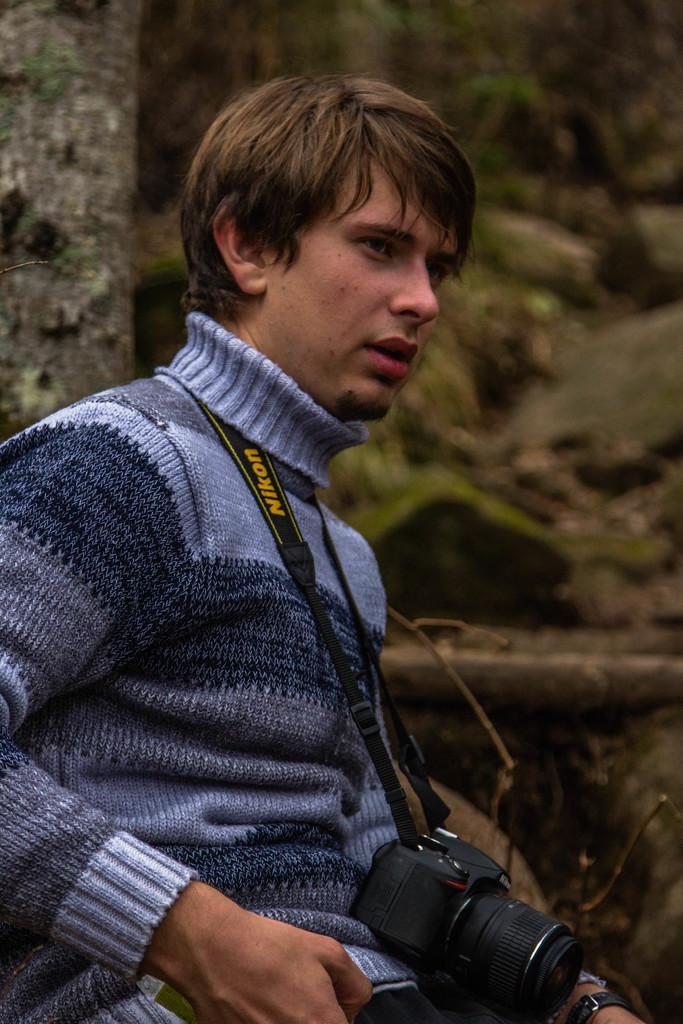Could you give a brief overview of what you see in this image? In this image I can see a man in the front and I can see he is wearing sweatshirt. I can also see he is carrying a black colour camera. Behind him I can see a tree trunk and I can also this image is little bit blurry in the background. 